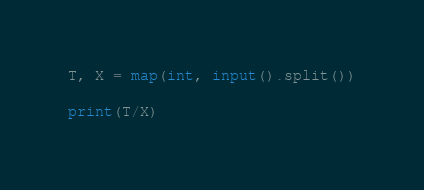<code> <loc_0><loc_0><loc_500><loc_500><_Python_>T, X = map(int, input().split())

print(T/X)</code> 